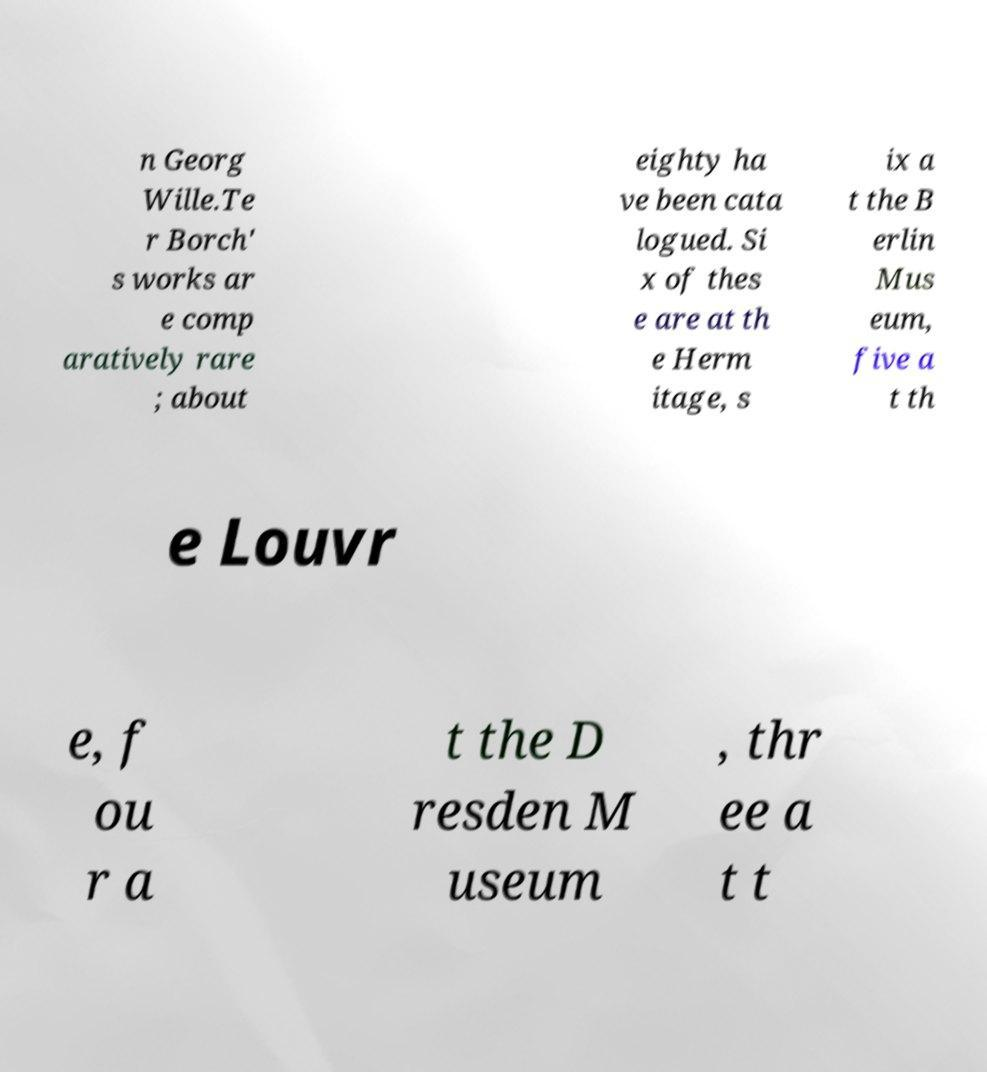Can you accurately transcribe the text from the provided image for me? n Georg Wille.Te r Borch' s works ar e comp aratively rare ; about eighty ha ve been cata logued. Si x of thes e are at th e Herm itage, s ix a t the B erlin Mus eum, five a t th e Louvr e, f ou r a t the D resden M useum , thr ee a t t 